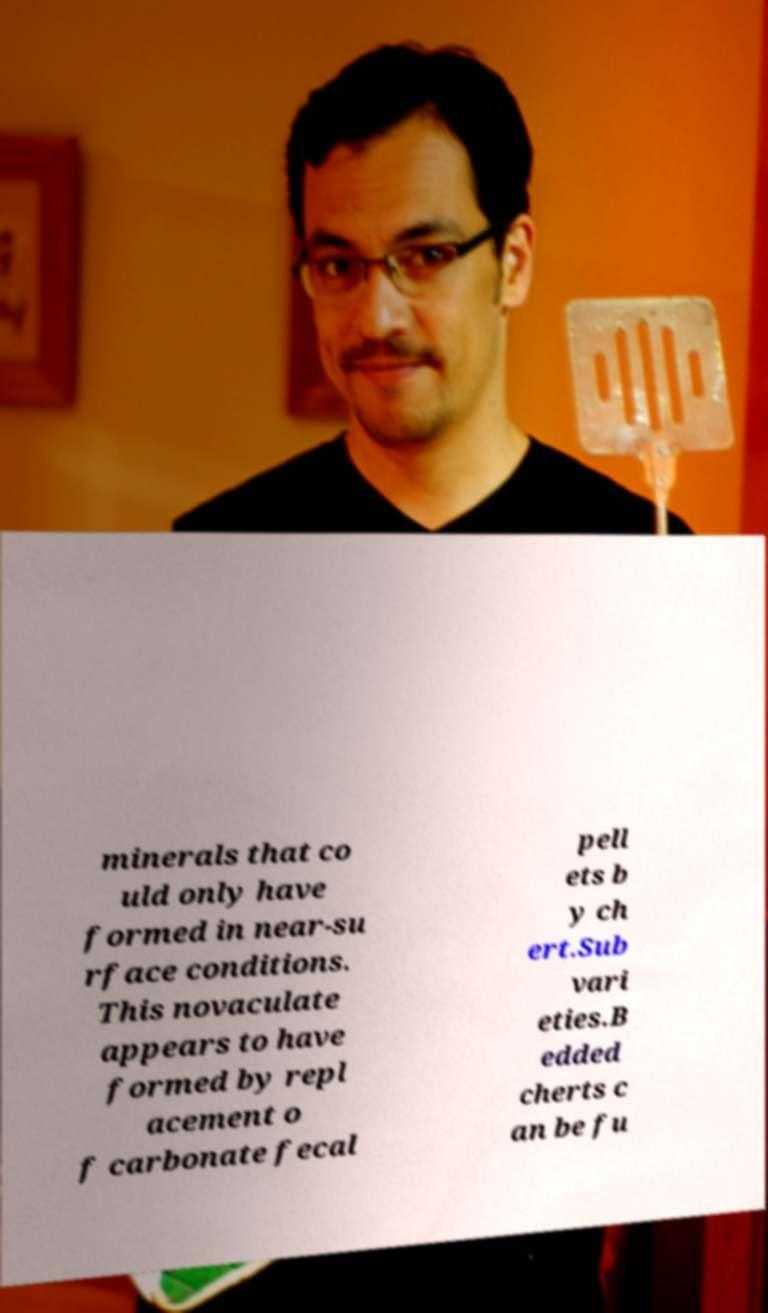Could you extract and type out the text from this image? minerals that co uld only have formed in near-su rface conditions. This novaculate appears to have formed by repl acement o f carbonate fecal pell ets b y ch ert.Sub vari eties.B edded cherts c an be fu 